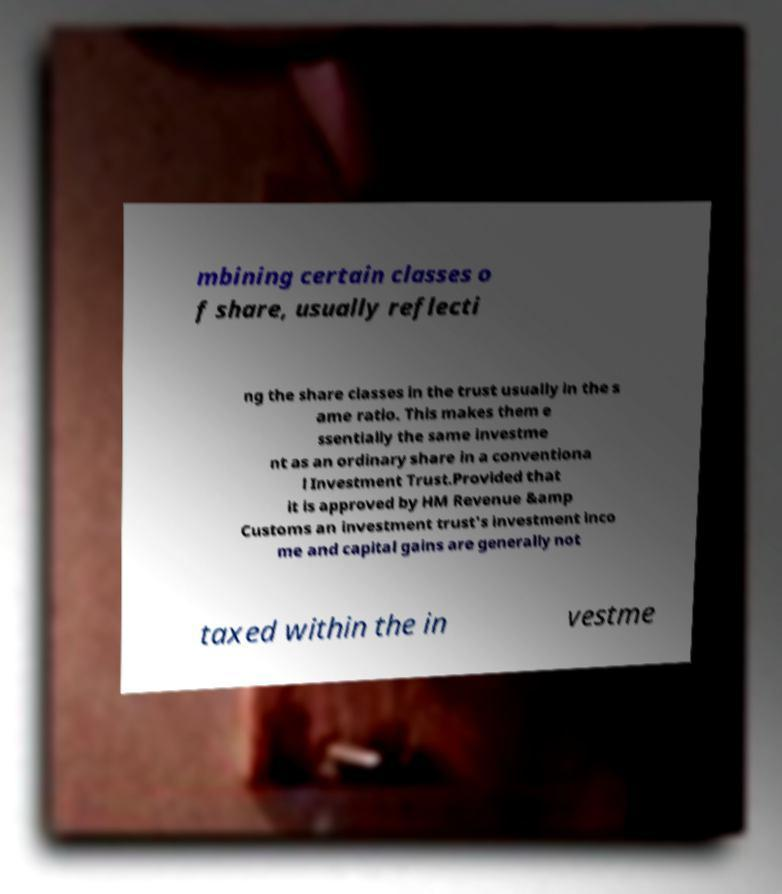For documentation purposes, I need the text within this image transcribed. Could you provide that? mbining certain classes o f share, usually reflecti ng the share classes in the trust usually in the s ame ratio. This makes them e ssentially the same investme nt as an ordinary share in a conventiona l Investment Trust.Provided that it is approved by HM Revenue &amp Customs an investment trust's investment inco me and capital gains are generally not taxed within the in vestme 